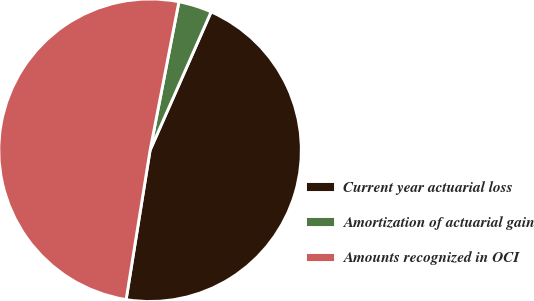Convert chart. <chart><loc_0><loc_0><loc_500><loc_500><pie_chart><fcel>Current year actuarial loss<fcel>Amortization of actuarial gain<fcel>Amounts recognized in OCI<nl><fcel>45.92%<fcel>3.56%<fcel>50.52%<nl></chart> 